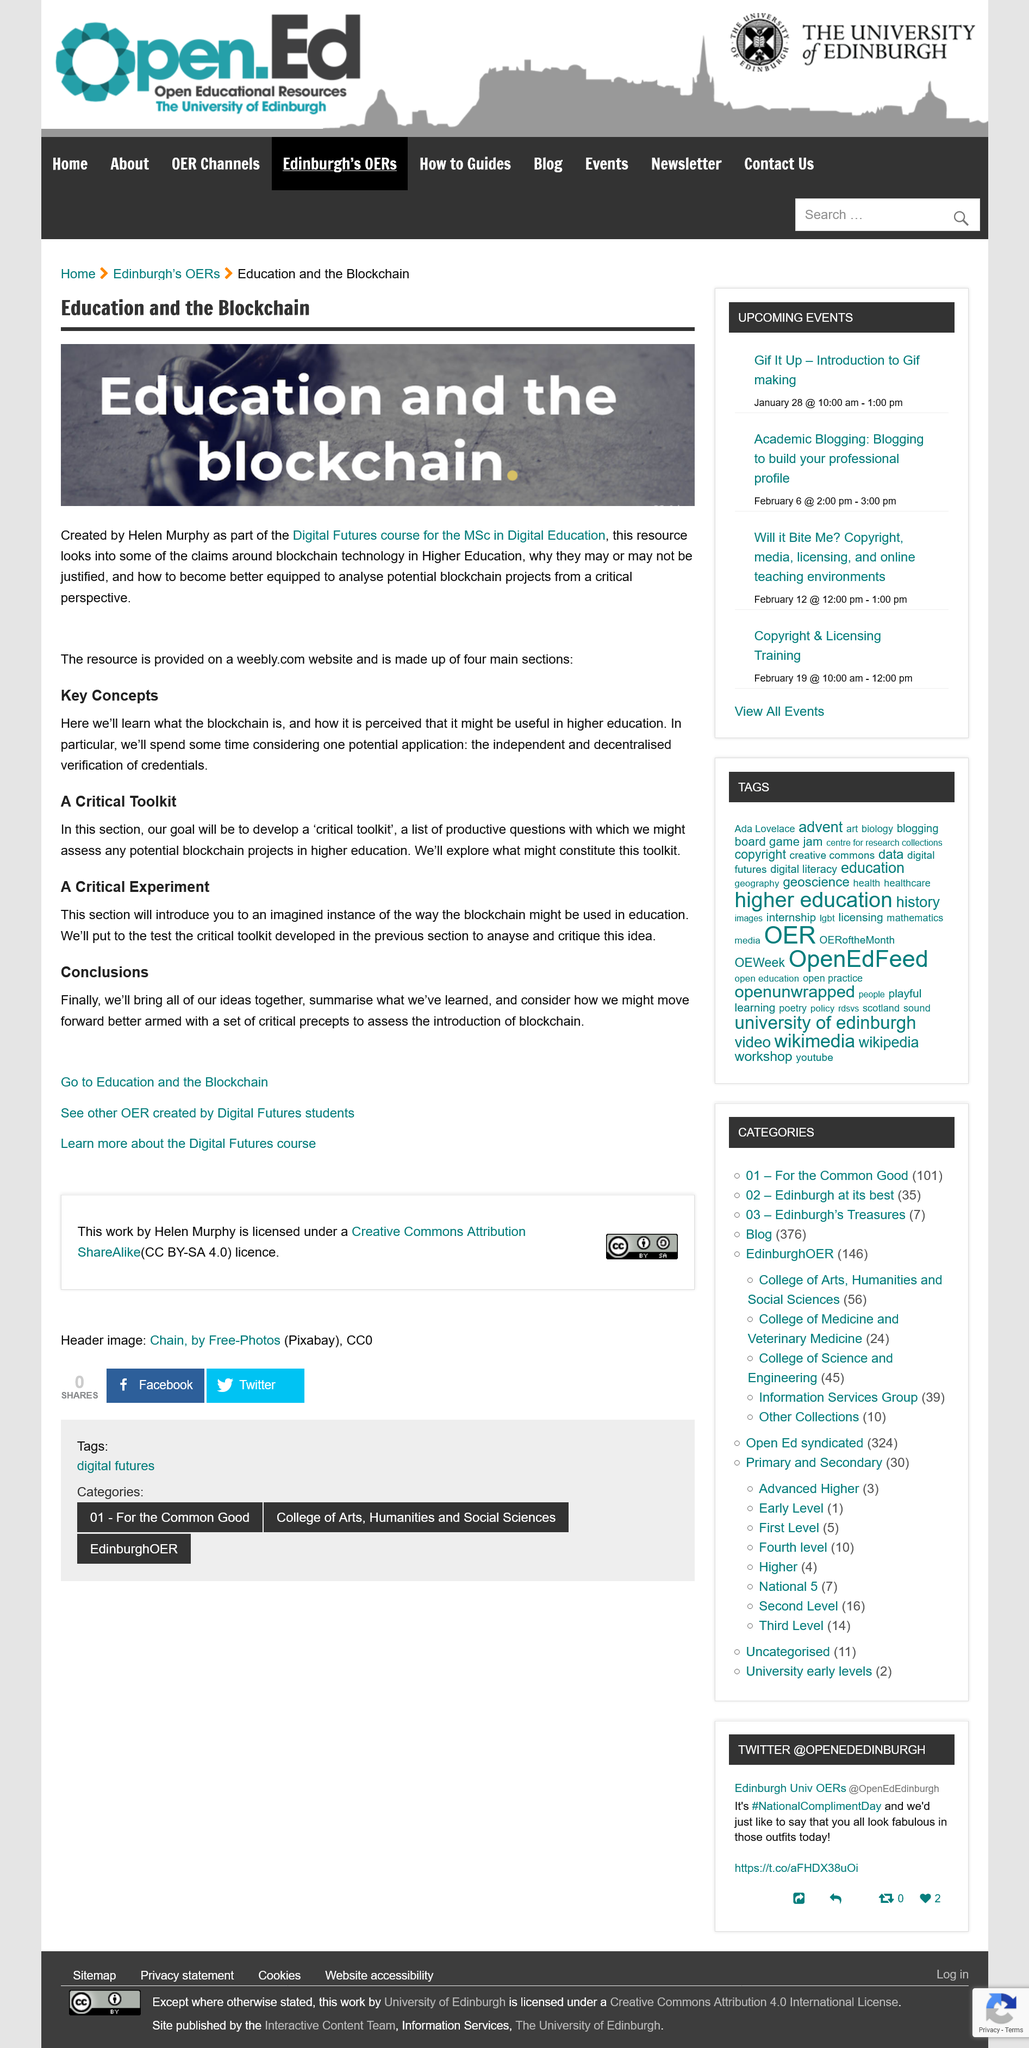Identify some key points in this picture. The goal of the assignment is to develop a critical toolkit through the analysis of a range of literary texts. The Digital Futures course is the one for which this assignment is intended. This resource was created by Helen Murphy. The title of this excerpt is 'Education and the Blockchain.' The key concepts will enable the independent and decentralized verification of credentials, paving the way for a potential application in the field. 